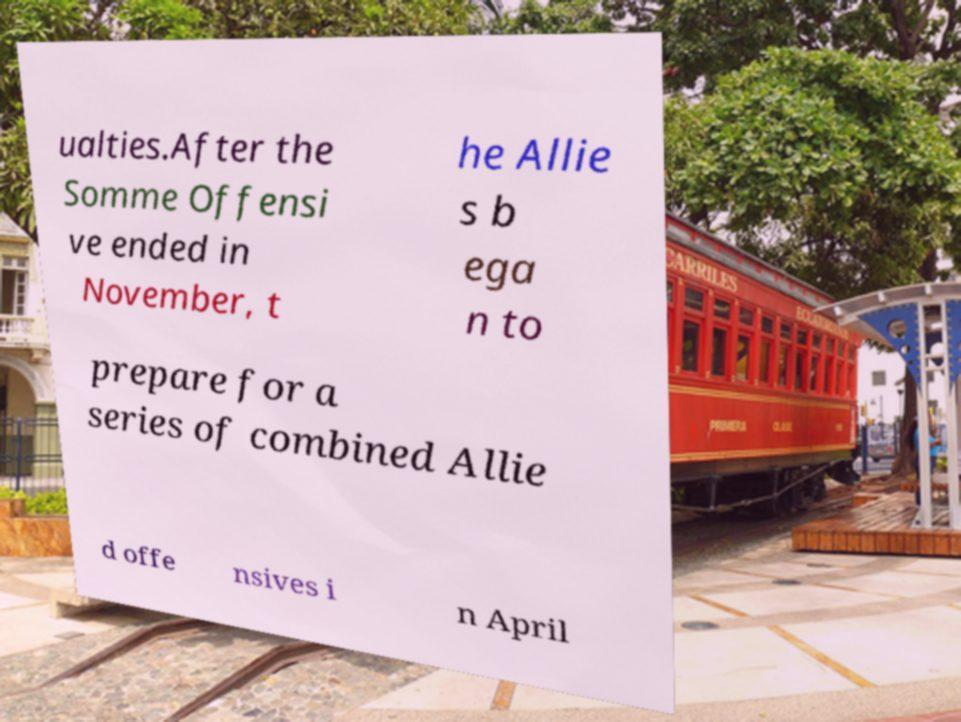Can you read and provide the text displayed in the image?This photo seems to have some interesting text. Can you extract and type it out for me? ualties.After the Somme Offensi ve ended in November, t he Allie s b ega n to prepare for a series of combined Allie d offe nsives i n April 